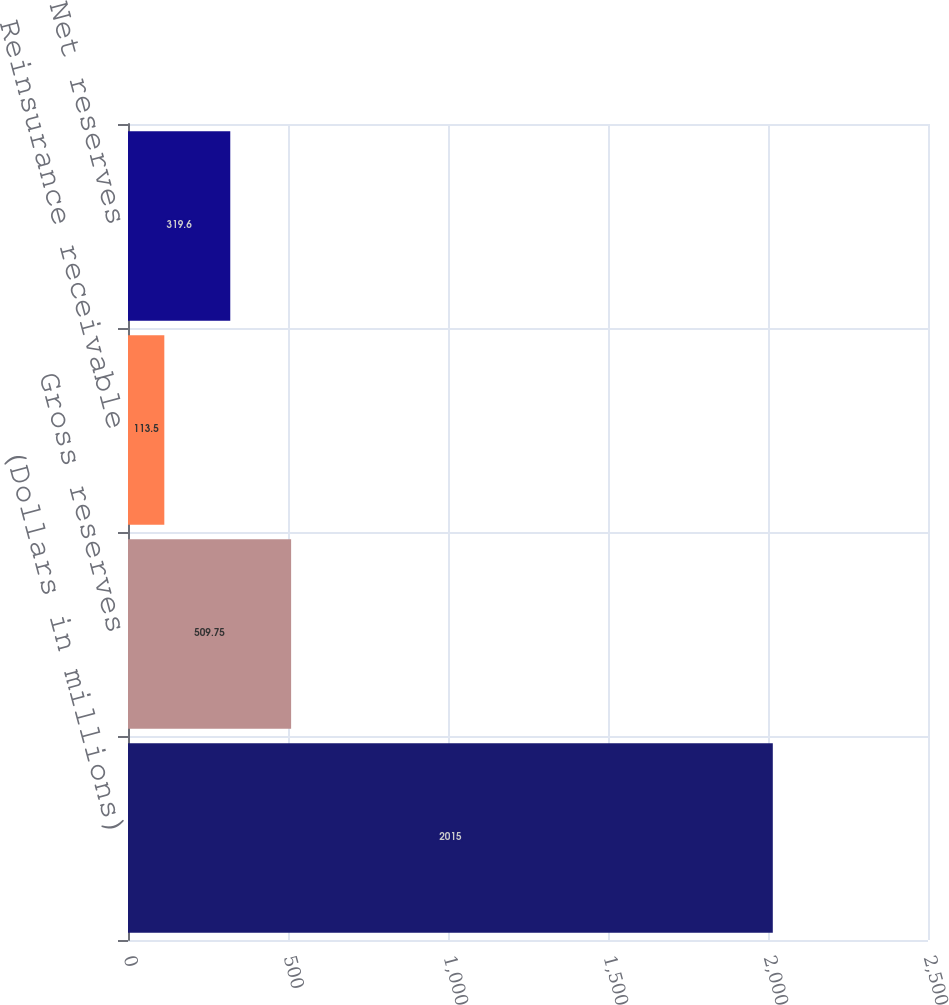Convert chart to OTSL. <chart><loc_0><loc_0><loc_500><loc_500><bar_chart><fcel>(Dollars in millions)<fcel>Gross reserves<fcel>Reinsurance receivable<fcel>Net reserves<nl><fcel>2015<fcel>509.75<fcel>113.5<fcel>319.6<nl></chart> 